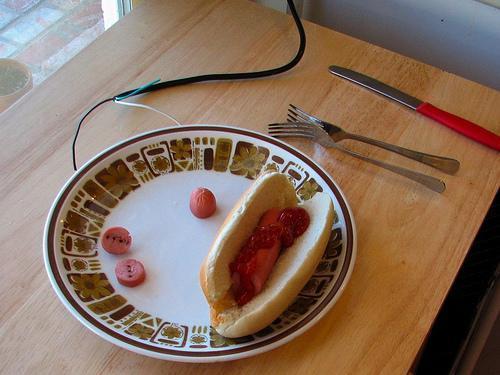How many forks are on the table?
Give a very brief answer. 2. How many people are wearing black shirt?
Give a very brief answer. 0. 